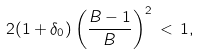Convert formula to latex. <formula><loc_0><loc_0><loc_500><loc_500>2 ( 1 + \delta _ { 0 } ) \left ( \frac { B - 1 } B \right ) ^ { 2 } \, < \, 1 ,</formula> 